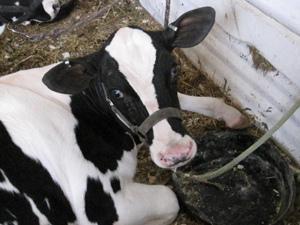How many cow's eyes do you see?
Give a very brief answer. 2. How many cars do you see?
Give a very brief answer. 0. 